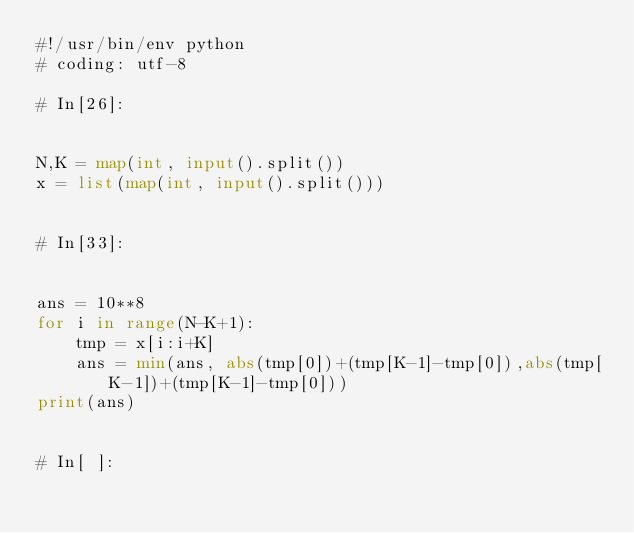<code> <loc_0><loc_0><loc_500><loc_500><_Python_>#!/usr/bin/env python
# coding: utf-8

# In[26]:


N,K = map(int, input().split())
x = list(map(int, input().split()))


# In[33]:


ans = 10**8
for i in range(N-K+1):
    tmp = x[i:i+K]
    ans = min(ans, abs(tmp[0])+(tmp[K-1]-tmp[0]),abs(tmp[K-1])+(tmp[K-1]-tmp[0]))
print(ans)


# In[ ]:




</code> 